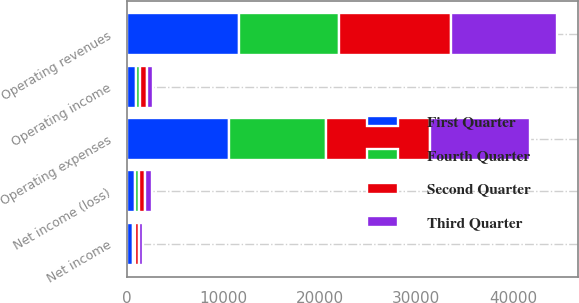Convert chart. <chart><loc_0><loc_0><loc_500><loc_500><stacked_bar_chart><ecel><fcel>Operating revenues<fcel>Operating expenses<fcel>Operating income<fcel>Net income<fcel>Net income (loss)<nl><fcel>Fourth Quarter<fcel>10398<fcel>9986<fcel>412<fcel>209<fcel>369<nl><fcel>First Quarter<fcel>11640<fcel>10626<fcel>1014<fcel>609<fcel>888<nl><fcel>Second Quarter<fcel>11556<fcel>10850<fcel>706<fcel>433<fcel>686<nl><fcel>Third Quarter<fcel>10936<fcel>10344<fcel>592<fcel>407<fcel>658<nl></chart> 